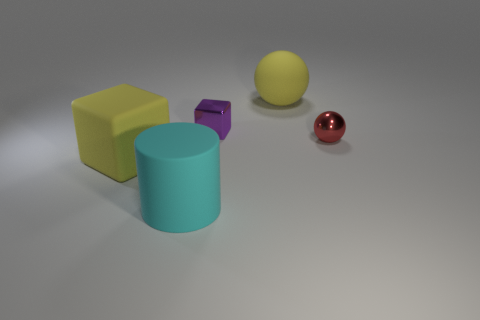Is there any other thing that has the same material as the small red sphere?
Ensure brevity in your answer.  Yes. The other object that is the same material as the tiny purple thing is what shape?
Ensure brevity in your answer.  Sphere. Is the number of yellow matte spheres that are in front of the yellow rubber sphere less than the number of small purple metal cubes that are to the left of the big cyan cylinder?
Make the answer very short. No. What number of large things are yellow rubber things or green balls?
Give a very brief answer. 2. There is a big rubber thing that is behind the small red sphere; does it have the same shape as the tiny shiny thing left of the large yellow rubber ball?
Provide a short and direct response. No. What is the size of the yellow rubber thing that is to the left of the sphere that is behind the cube that is behind the red thing?
Ensure brevity in your answer.  Large. There is a yellow object that is to the left of the rubber sphere; what is its size?
Provide a short and direct response. Large. What material is the purple object left of the red metallic object?
Provide a succinct answer. Metal. What number of gray things are either matte cubes or metallic things?
Offer a terse response. 0. Are the tiny red sphere and the large yellow thing that is to the left of the small metallic cube made of the same material?
Ensure brevity in your answer.  No. 